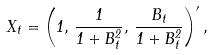Convert formula to latex. <formula><loc_0><loc_0><loc_500><loc_500>X _ { t } = \left ( 1 , \, \frac { 1 } { 1 + B _ { t } ^ { 2 } } , \, \frac { B _ { t } } { 1 + B _ { t } ^ { 2 } } \right ) ^ { \prime } ,</formula> 